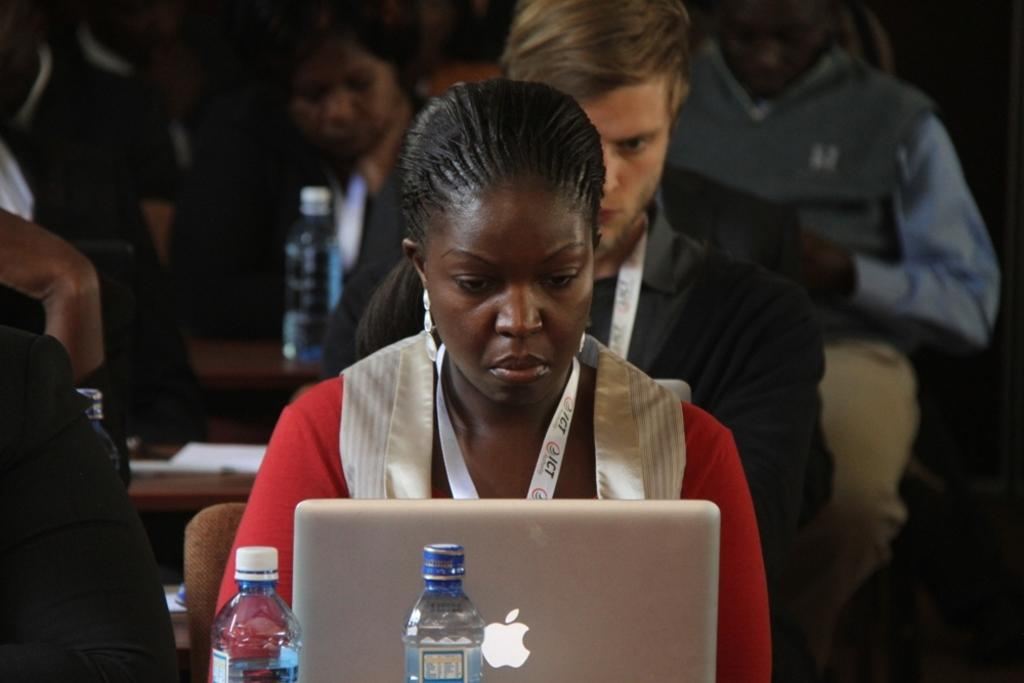What are the people in the image doing? The people in the image are sitting. What type of furniture is present in the image? There are tables in the image. What electronic device can be seen on a table? There is at least one laptop on a table. What else is present on the tables in the image? There are bottles on a table. How many clovers are on the table in the image? There are no clovers present in the image. What is the point of the laptop in the image? The laptop in the image is not performing any specific action or task, so it is not possible to determine its point. 